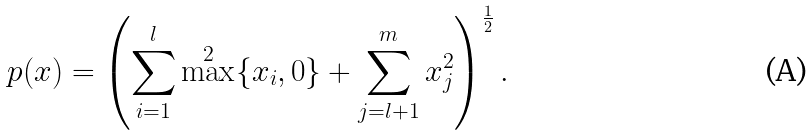Convert formula to latex. <formula><loc_0><loc_0><loc_500><loc_500>p ( x ) = \left ( \sum _ { i = 1 } ^ { l } \max ^ { 2 } \{ x _ { i } , 0 \} + \sum _ { j = l + 1 } ^ { m } x _ { j } ^ { 2 } \right ) ^ { \frac { 1 } { 2 } } .</formula> 